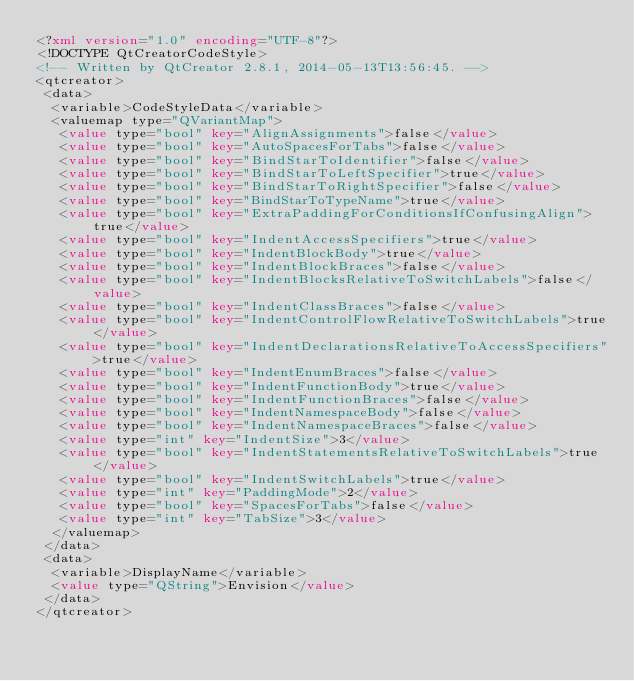<code> <loc_0><loc_0><loc_500><loc_500><_XML_><?xml version="1.0" encoding="UTF-8"?>
<!DOCTYPE QtCreatorCodeStyle>
<!-- Written by QtCreator 2.8.1, 2014-05-13T13:56:45. -->
<qtcreator>
 <data>
  <variable>CodeStyleData</variable>
  <valuemap type="QVariantMap">
   <value type="bool" key="AlignAssignments">false</value>
   <value type="bool" key="AutoSpacesForTabs">false</value>
   <value type="bool" key="BindStarToIdentifier">false</value>
   <value type="bool" key="BindStarToLeftSpecifier">true</value>
   <value type="bool" key="BindStarToRightSpecifier">false</value>
   <value type="bool" key="BindStarToTypeName">true</value>
   <value type="bool" key="ExtraPaddingForConditionsIfConfusingAlign">true</value>
   <value type="bool" key="IndentAccessSpecifiers">true</value>
   <value type="bool" key="IndentBlockBody">true</value>
   <value type="bool" key="IndentBlockBraces">false</value>
   <value type="bool" key="IndentBlocksRelativeToSwitchLabels">false</value>
   <value type="bool" key="IndentClassBraces">false</value>
   <value type="bool" key="IndentControlFlowRelativeToSwitchLabels">true</value>
   <value type="bool" key="IndentDeclarationsRelativeToAccessSpecifiers">true</value>
   <value type="bool" key="IndentEnumBraces">false</value>
   <value type="bool" key="IndentFunctionBody">true</value>
   <value type="bool" key="IndentFunctionBraces">false</value>
   <value type="bool" key="IndentNamespaceBody">false</value>
   <value type="bool" key="IndentNamespaceBraces">false</value>
   <value type="int" key="IndentSize">3</value>
   <value type="bool" key="IndentStatementsRelativeToSwitchLabels">true</value>
   <value type="bool" key="IndentSwitchLabels">true</value>
   <value type="int" key="PaddingMode">2</value>
   <value type="bool" key="SpacesForTabs">false</value>
   <value type="int" key="TabSize">3</value>
  </valuemap>
 </data>
 <data>
  <variable>DisplayName</variable>
  <value type="QString">Envision</value>
 </data>
</qtcreator>
</code> 